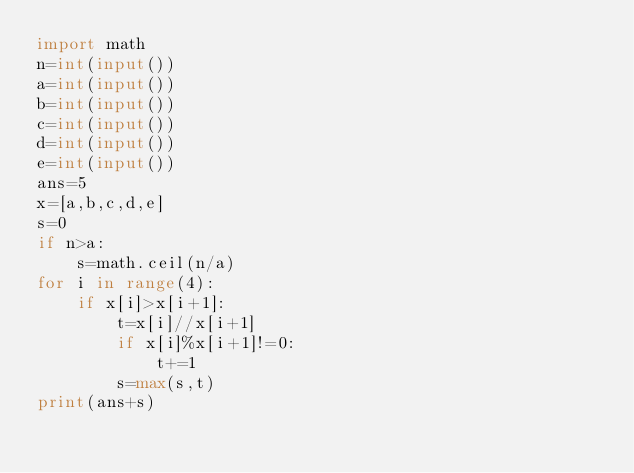Convert code to text. <code><loc_0><loc_0><loc_500><loc_500><_Python_>import math
n=int(input())
a=int(input())
b=int(input())
c=int(input())
d=int(input())
e=int(input())
ans=5
x=[a,b,c,d,e]
s=0
if n>a:
    s=math.ceil(n/a)
for i in range(4):
    if x[i]>x[i+1]:
        t=x[i]//x[i+1]
        if x[i]%x[i+1]!=0:
            t+=1
        s=max(s,t)
print(ans+s)
</code> 